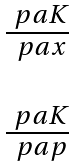Convert formula to latex. <formula><loc_0><loc_0><loc_500><loc_500>\begin{matrix} \frac { \ p a K } { \ p a x } \\ \\ \frac { \ p a K } { \ p a p } \end{matrix}</formula> 